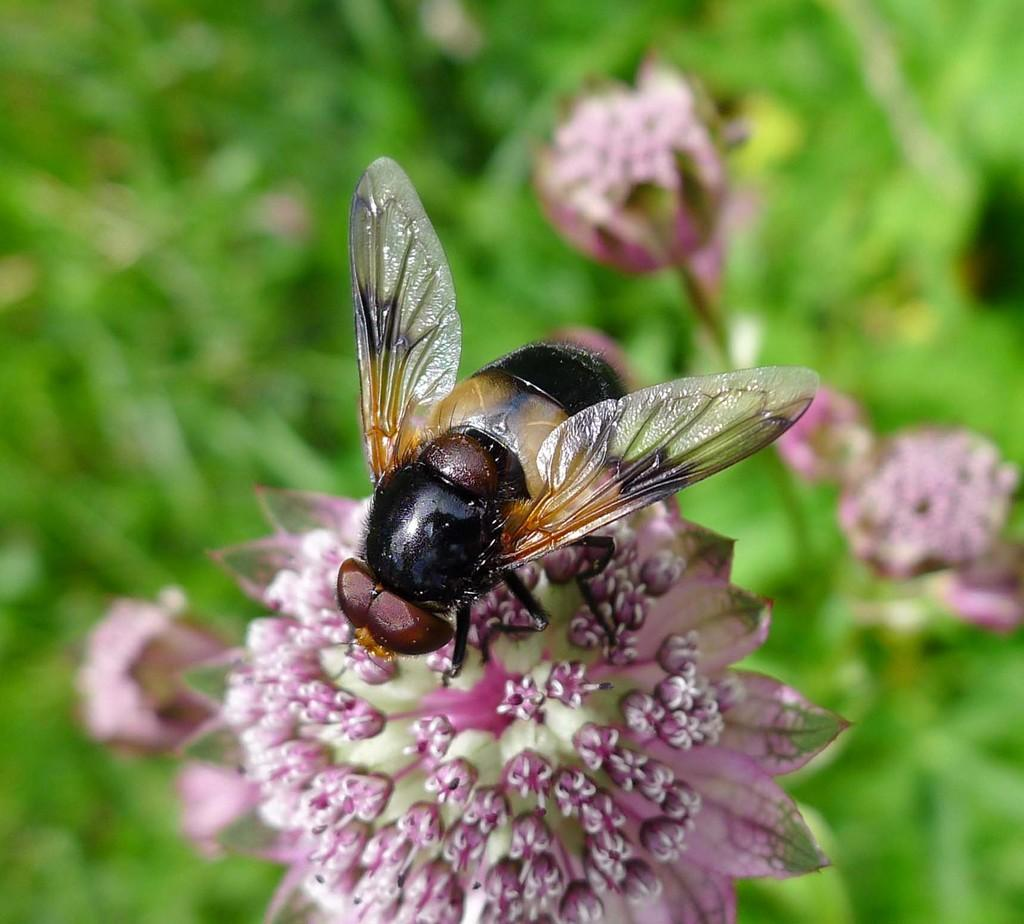What is present on the flower in the image? There is an insect on the flower in the image. What is the insect's location in relation to the flower? The insect is on the flower. What can be seen in the background of the image? The background of the image includes leaves and flowers. What type of acoustics can be heard from the waste in the image? There is no waste present in the image, and therefore no acoustics can be heard from it. 